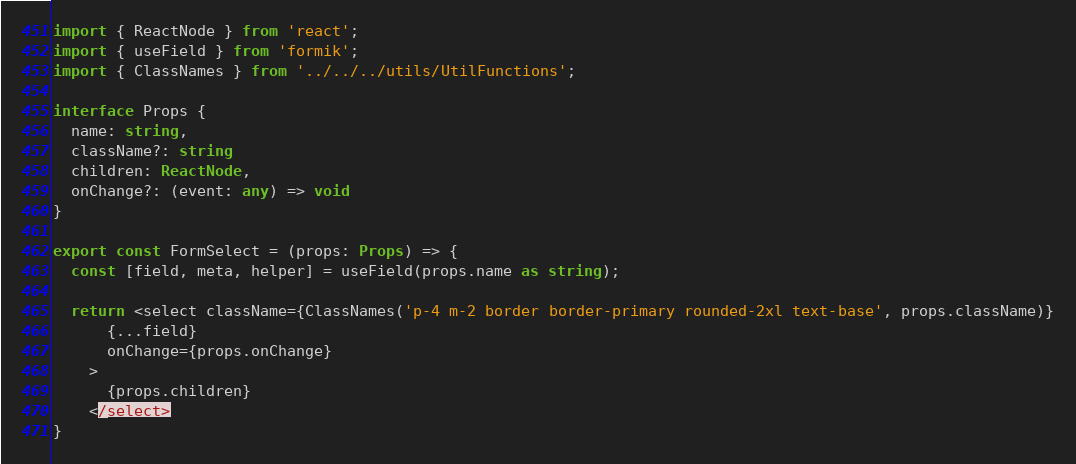<code> <loc_0><loc_0><loc_500><loc_500><_TypeScript_>import { ReactNode } from 'react';
import { useField } from 'formik';
import { ClassNames } from '../../../utils/UtilFunctions';

interface Props {
  name: string,
  className?: string
  children: ReactNode,
  onChange?: (event: any) => void
}

export const FormSelect = (props: Props) => {
  const [field, meta, helper] = useField(props.name as string);

  return <select className={ClassNames('p-4 m-2 border border-primary rounded-2xl text-base', props.className)}
      {...field}
      onChange={props.onChange}
    >
      {props.children}
    </select>
}</code> 